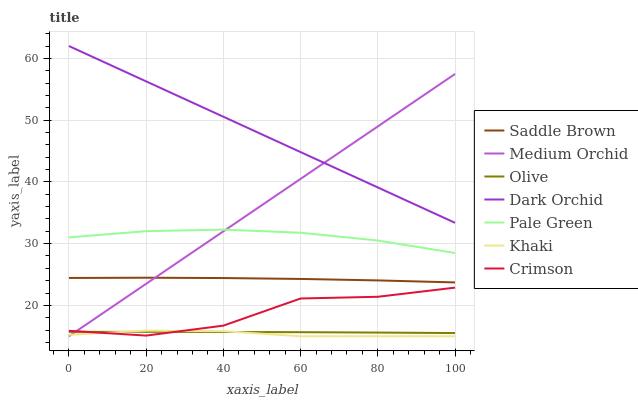Does Khaki have the minimum area under the curve?
Answer yes or no. Yes. Does Dark Orchid have the maximum area under the curve?
Answer yes or no. Yes. Does Medium Orchid have the minimum area under the curve?
Answer yes or no. No. Does Medium Orchid have the maximum area under the curve?
Answer yes or no. No. Is Dark Orchid the smoothest?
Answer yes or no. Yes. Is Crimson the roughest?
Answer yes or no. Yes. Is Medium Orchid the smoothest?
Answer yes or no. No. Is Medium Orchid the roughest?
Answer yes or no. No. Does Dark Orchid have the lowest value?
Answer yes or no. No. Does Dark Orchid have the highest value?
Answer yes or no. Yes. Does Medium Orchid have the highest value?
Answer yes or no. No. Is Khaki less than Saddle Brown?
Answer yes or no. Yes. Is Pale Green greater than Saddle Brown?
Answer yes or no. Yes. Does Khaki intersect Crimson?
Answer yes or no. Yes. Is Khaki less than Crimson?
Answer yes or no. No. Is Khaki greater than Crimson?
Answer yes or no. No. Does Khaki intersect Saddle Brown?
Answer yes or no. No. 